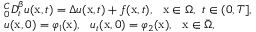Convert formula to latex. <formula><loc_0><loc_0><loc_500><loc_500>\begin{array} { r l } & { _ { 0 } ^ { C } D _ { t } ^ { \beta } u ( x , t ) = \Delta u ( x , t ) + f ( x , t ) , x \in \Omega , t \in ( 0 , T ] , } \\ & { u ( x , 0 ) = \varphi _ { 1 } ( x ) , u _ { t } ( x , 0 ) = \varphi _ { 2 } ( x ) , x \in \bar { \Omega } , } \end{array}</formula> 